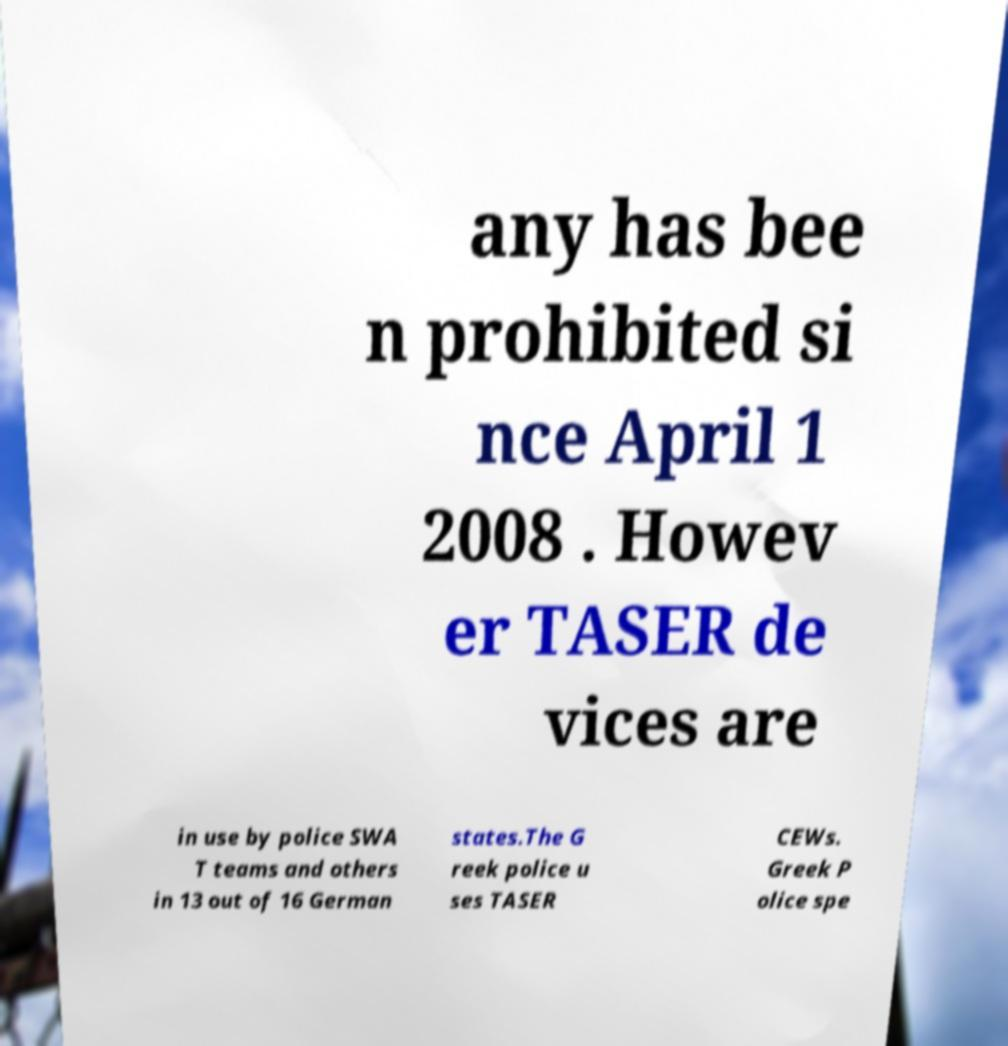For documentation purposes, I need the text within this image transcribed. Could you provide that? any has bee n prohibited si nce April 1 2008 . Howev er TASER de vices are in use by police SWA T teams and others in 13 out of 16 German states.The G reek police u ses TASER CEWs. Greek P olice spe 